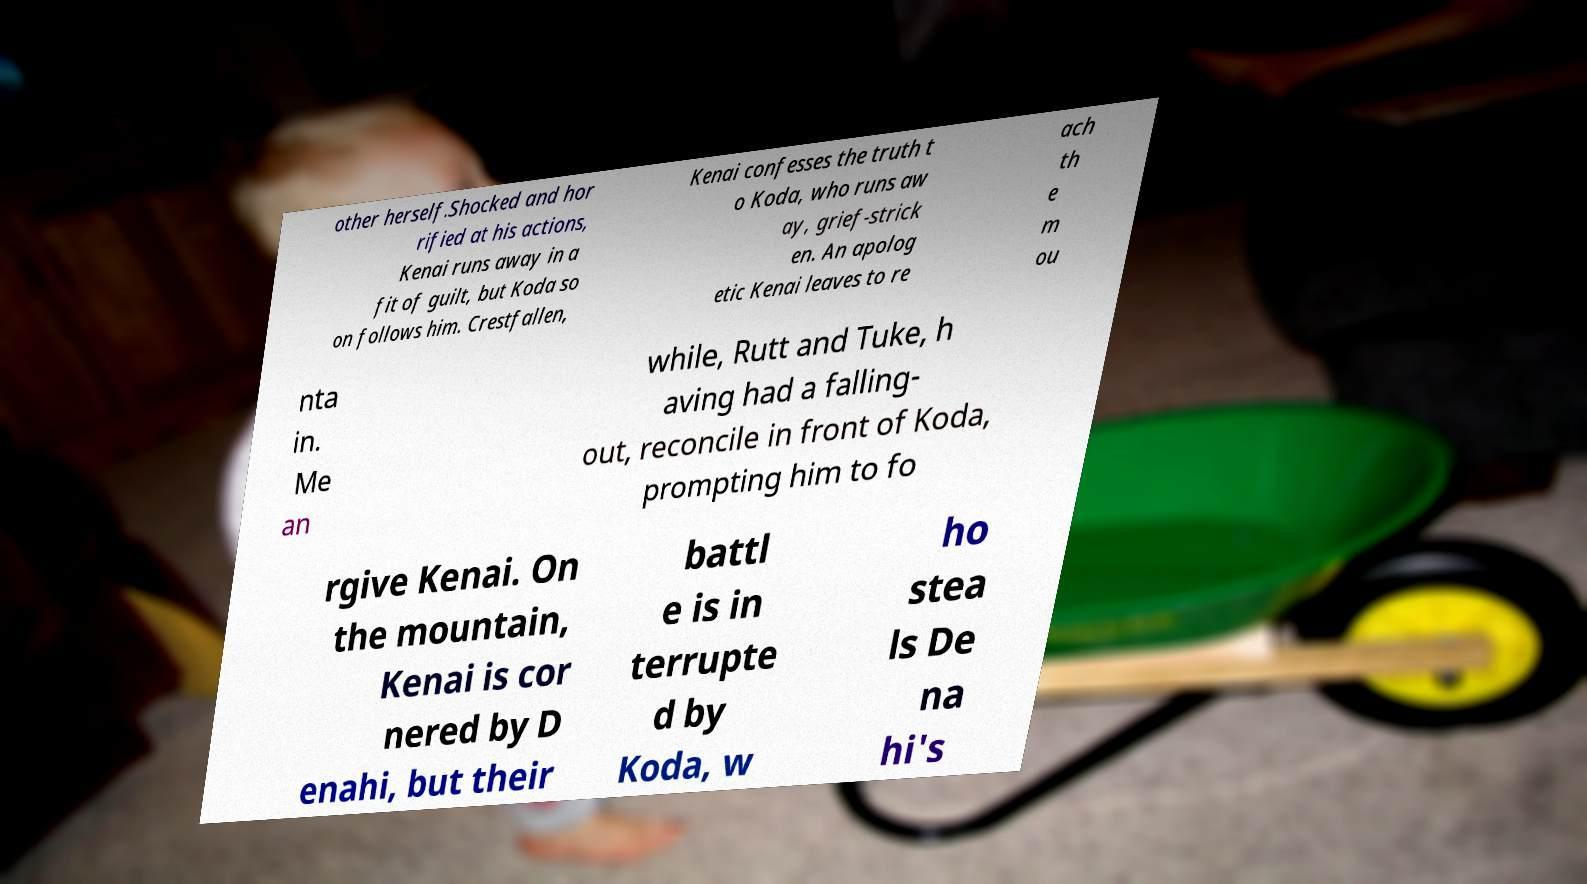For documentation purposes, I need the text within this image transcribed. Could you provide that? other herself.Shocked and hor rified at his actions, Kenai runs away in a fit of guilt, but Koda so on follows him. Crestfallen, Kenai confesses the truth t o Koda, who runs aw ay, grief-strick en. An apolog etic Kenai leaves to re ach th e m ou nta in. Me an while, Rutt and Tuke, h aving had a falling- out, reconcile in front of Koda, prompting him to fo rgive Kenai. On the mountain, Kenai is cor nered by D enahi, but their battl e is in terrupte d by Koda, w ho stea ls De na hi's 